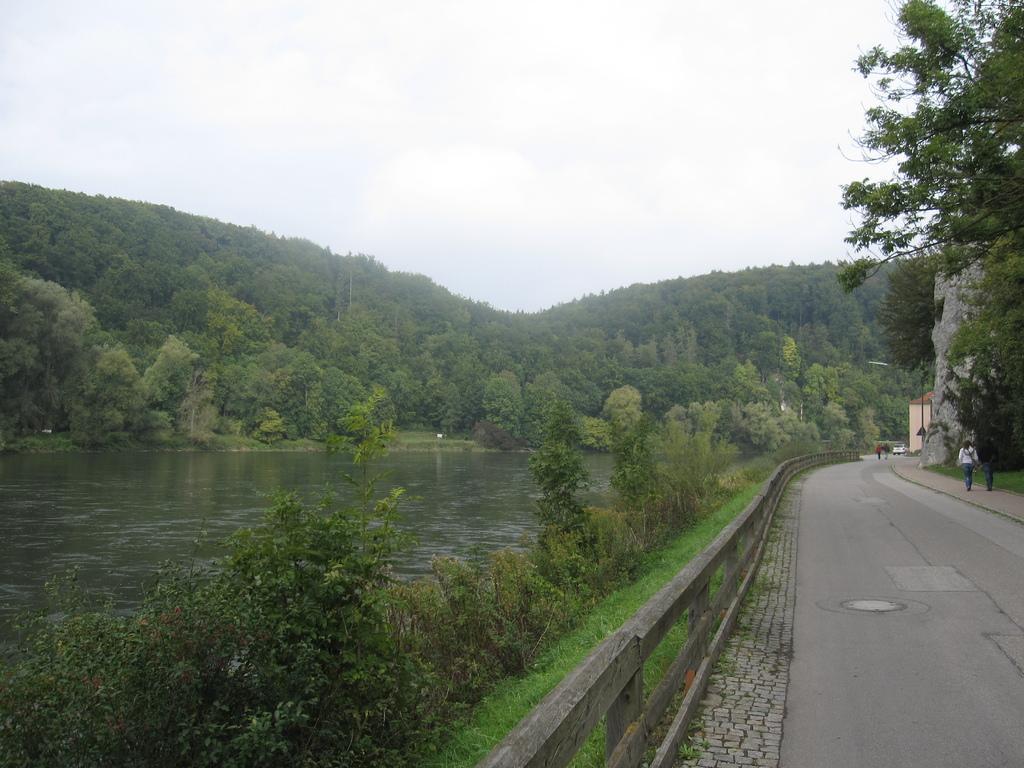Can you describe this image briefly? In the picture I can see the road on the right side and there is a fence on the side of the road. I can see two people walking on the side of the road. I can see a lake on the left side. I can see the plants on the side of the lake. In the background, I can see the trees. 